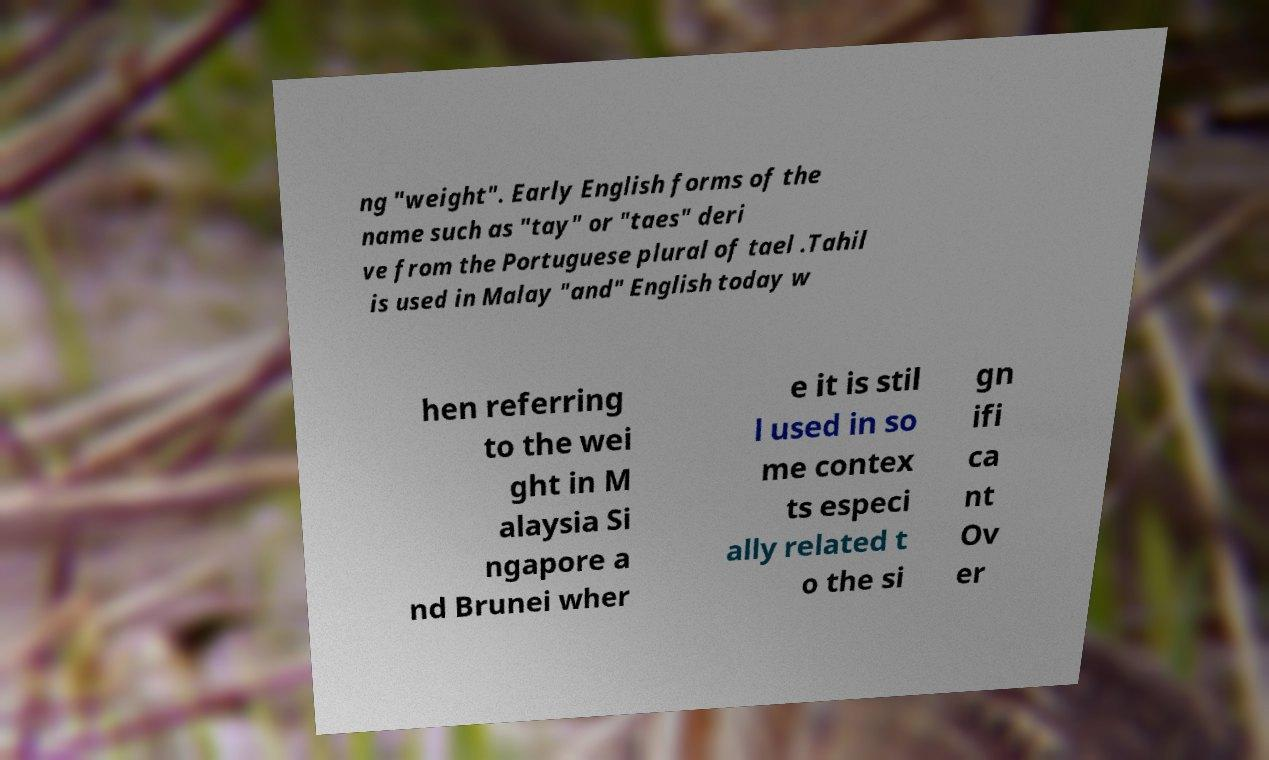Could you extract and type out the text from this image? ng "weight". Early English forms of the name such as "tay" or "taes" deri ve from the Portuguese plural of tael .Tahil is used in Malay "and" English today w hen referring to the wei ght in M alaysia Si ngapore a nd Brunei wher e it is stil l used in so me contex ts especi ally related t o the si gn ifi ca nt Ov er 